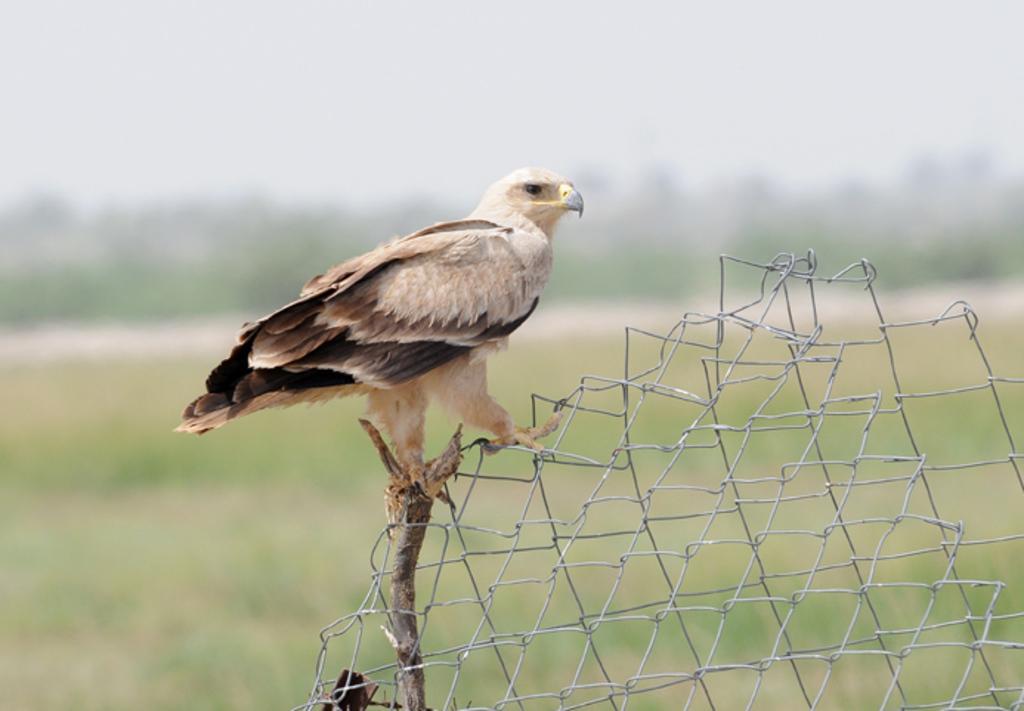How would you summarize this image in a sentence or two? In this image in front there is a bird on the metal fence. At the bottom of the image there is grass on the surface. In the background of the image there are trees and sky. 